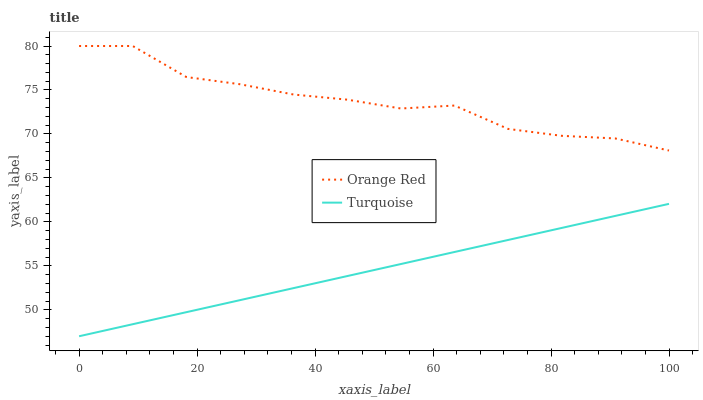Does Turquoise have the minimum area under the curve?
Answer yes or no. Yes. Does Orange Red have the maximum area under the curve?
Answer yes or no. Yes. Does Orange Red have the minimum area under the curve?
Answer yes or no. No. Is Turquoise the smoothest?
Answer yes or no. Yes. Is Orange Red the roughest?
Answer yes or no. Yes. Is Orange Red the smoothest?
Answer yes or no. No. Does Turquoise have the lowest value?
Answer yes or no. Yes. Does Orange Red have the lowest value?
Answer yes or no. No. Does Orange Red have the highest value?
Answer yes or no. Yes. Is Turquoise less than Orange Red?
Answer yes or no. Yes. Is Orange Red greater than Turquoise?
Answer yes or no. Yes. Does Turquoise intersect Orange Red?
Answer yes or no. No. 